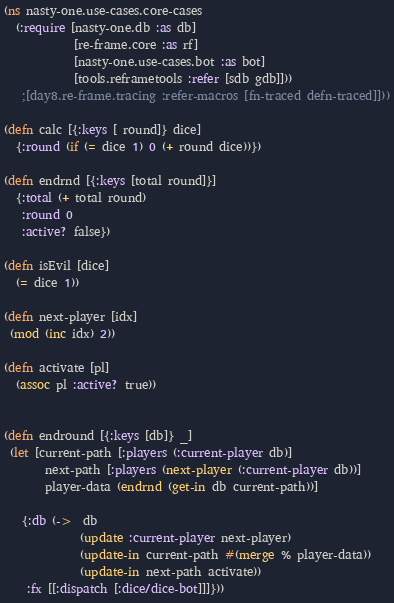<code> <loc_0><loc_0><loc_500><loc_500><_Clojure_>(ns nasty-one.use-cases.core-cases
  (:require [nasty-one.db :as db]
            [re-frame.core :as rf]
            [nasty-one.use-cases.bot :as bot]
            [tools.reframetools :refer [sdb gdb]]))
   ;[day8.re-frame.tracing :refer-macros [fn-traced defn-traced]]))

(defn calc [{:keys [ round]} dice]
  {:round (if (= dice 1) 0 (+ round dice))})

(defn endrnd [{:keys [total round]}]
  {:total (+ total round)
   :round 0
   :active? false})

(defn isEvil [dice]
  (= dice 1))

(defn next-player [idx]
 (mod (inc idx) 2))

(defn activate [pl]
  (assoc pl :active? true))


(defn endround [{:keys [db]} _]
 (let [current-path [:players (:current-player db)]
       next-path [:players (next-player (:current-player db))]
       player-data (endrnd (get-in db current-path))]
       
   {:db (->  db
             (update :current-player next-player)
             (update-in current-path #(merge % player-data))
             (update-in next-path activate))
    :fx [[:dispatch [:dice/dice-bot]]]}))
</code> 